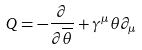Convert formula to latex. <formula><loc_0><loc_0><loc_500><loc_500>Q = - \frac { \partial } { \partial \overline { \theta } } + \gamma ^ { \mu } \theta \partial _ { \mu }</formula> 